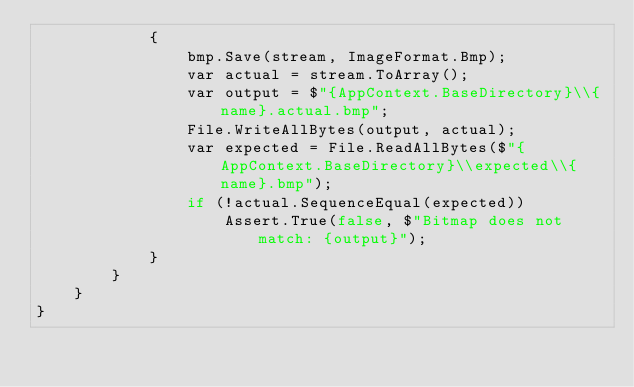Convert code to text. <code><loc_0><loc_0><loc_500><loc_500><_C#_>            {
                bmp.Save(stream, ImageFormat.Bmp);
                var actual = stream.ToArray();
                var output = $"{AppContext.BaseDirectory}\\{name}.actual.bmp";
                File.WriteAllBytes(output, actual);
                var expected = File.ReadAllBytes($"{AppContext.BaseDirectory}\\expected\\{name}.bmp");
                if (!actual.SequenceEqual(expected))
                    Assert.True(false, $"Bitmap does not match: {output}");
            }
        }
    }
}</code> 